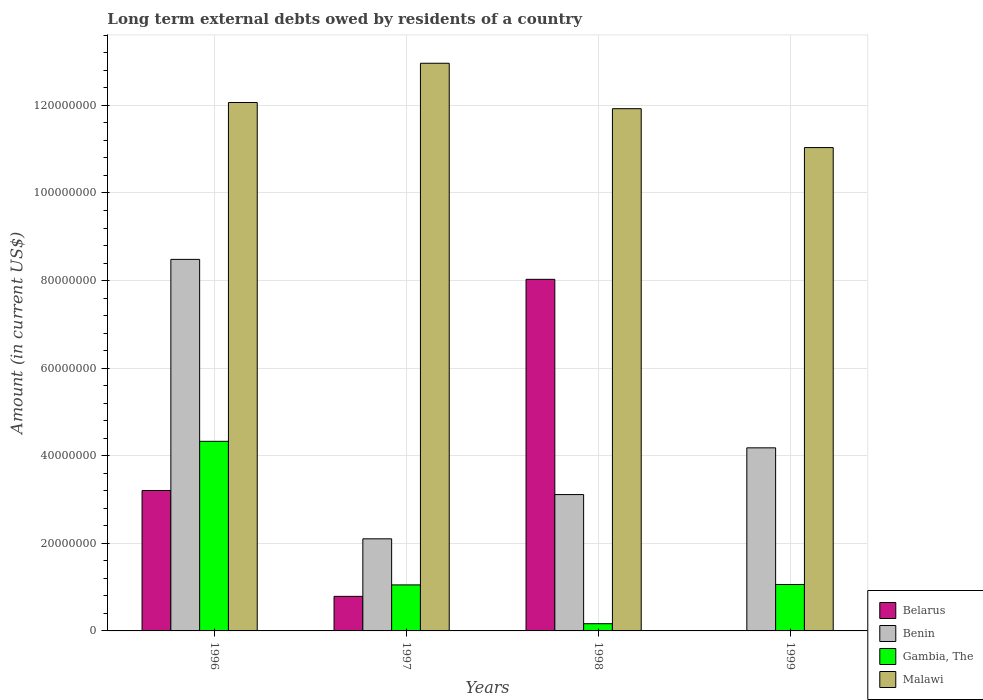Are the number of bars per tick equal to the number of legend labels?
Keep it short and to the point. No. What is the label of the 1st group of bars from the left?
Offer a very short reply. 1996. What is the amount of long-term external debts owed by residents in Gambia, The in 1998?
Your answer should be very brief. 1.65e+06. Across all years, what is the maximum amount of long-term external debts owed by residents in Belarus?
Offer a terse response. 8.03e+07. Across all years, what is the minimum amount of long-term external debts owed by residents in Belarus?
Your answer should be compact. 0. What is the total amount of long-term external debts owed by residents in Benin in the graph?
Your response must be concise. 1.79e+08. What is the difference between the amount of long-term external debts owed by residents in Benin in 1998 and that in 1999?
Give a very brief answer. -1.07e+07. What is the difference between the amount of long-term external debts owed by residents in Malawi in 1997 and the amount of long-term external debts owed by residents in Benin in 1996?
Provide a short and direct response. 4.48e+07. What is the average amount of long-term external debts owed by residents in Gambia, The per year?
Give a very brief answer. 1.65e+07. In the year 1996, what is the difference between the amount of long-term external debts owed by residents in Gambia, The and amount of long-term external debts owed by residents in Belarus?
Offer a terse response. 1.12e+07. What is the ratio of the amount of long-term external debts owed by residents in Benin in 1996 to that in 1998?
Give a very brief answer. 2.72. Is the amount of long-term external debts owed by residents in Malawi in 1997 less than that in 1999?
Ensure brevity in your answer.  No. What is the difference between the highest and the second highest amount of long-term external debts owed by residents in Benin?
Give a very brief answer. 4.30e+07. What is the difference between the highest and the lowest amount of long-term external debts owed by residents in Gambia, The?
Keep it short and to the point. 4.16e+07. In how many years, is the amount of long-term external debts owed by residents in Malawi greater than the average amount of long-term external debts owed by residents in Malawi taken over all years?
Your response must be concise. 2. Is it the case that in every year, the sum of the amount of long-term external debts owed by residents in Benin and amount of long-term external debts owed by residents in Malawi is greater than the sum of amount of long-term external debts owed by residents in Belarus and amount of long-term external debts owed by residents in Gambia, The?
Your answer should be compact. Yes. How many years are there in the graph?
Your answer should be compact. 4. What is the difference between two consecutive major ticks on the Y-axis?
Provide a short and direct response. 2.00e+07. Are the values on the major ticks of Y-axis written in scientific E-notation?
Provide a succinct answer. No. Where does the legend appear in the graph?
Your answer should be very brief. Bottom right. How are the legend labels stacked?
Keep it short and to the point. Vertical. What is the title of the graph?
Your response must be concise. Long term external debts owed by residents of a country. What is the Amount (in current US$) in Belarus in 1996?
Offer a very short reply. 3.21e+07. What is the Amount (in current US$) in Benin in 1996?
Make the answer very short. 8.48e+07. What is the Amount (in current US$) of Gambia, The in 1996?
Provide a short and direct response. 4.33e+07. What is the Amount (in current US$) of Malawi in 1996?
Your answer should be compact. 1.21e+08. What is the Amount (in current US$) of Belarus in 1997?
Provide a short and direct response. 7.89e+06. What is the Amount (in current US$) in Benin in 1997?
Make the answer very short. 2.10e+07. What is the Amount (in current US$) of Gambia, The in 1997?
Offer a very short reply. 1.05e+07. What is the Amount (in current US$) in Malawi in 1997?
Your response must be concise. 1.30e+08. What is the Amount (in current US$) in Belarus in 1998?
Make the answer very short. 8.03e+07. What is the Amount (in current US$) of Benin in 1998?
Offer a very short reply. 3.11e+07. What is the Amount (in current US$) of Gambia, The in 1998?
Offer a very short reply. 1.65e+06. What is the Amount (in current US$) in Malawi in 1998?
Ensure brevity in your answer.  1.19e+08. What is the Amount (in current US$) of Belarus in 1999?
Offer a very short reply. 0. What is the Amount (in current US$) in Benin in 1999?
Keep it short and to the point. 4.18e+07. What is the Amount (in current US$) of Gambia, The in 1999?
Offer a very short reply. 1.06e+07. What is the Amount (in current US$) of Malawi in 1999?
Keep it short and to the point. 1.10e+08. Across all years, what is the maximum Amount (in current US$) of Belarus?
Provide a short and direct response. 8.03e+07. Across all years, what is the maximum Amount (in current US$) of Benin?
Give a very brief answer. 8.48e+07. Across all years, what is the maximum Amount (in current US$) in Gambia, The?
Provide a succinct answer. 4.33e+07. Across all years, what is the maximum Amount (in current US$) of Malawi?
Your answer should be very brief. 1.30e+08. Across all years, what is the minimum Amount (in current US$) in Benin?
Offer a very short reply. 2.10e+07. Across all years, what is the minimum Amount (in current US$) in Gambia, The?
Offer a very short reply. 1.65e+06. Across all years, what is the minimum Amount (in current US$) in Malawi?
Ensure brevity in your answer.  1.10e+08. What is the total Amount (in current US$) in Belarus in the graph?
Provide a short and direct response. 1.20e+08. What is the total Amount (in current US$) of Benin in the graph?
Provide a succinct answer. 1.79e+08. What is the total Amount (in current US$) in Gambia, The in the graph?
Your answer should be very brief. 6.60e+07. What is the total Amount (in current US$) of Malawi in the graph?
Provide a succinct answer. 4.80e+08. What is the difference between the Amount (in current US$) of Belarus in 1996 and that in 1997?
Your answer should be compact. 2.42e+07. What is the difference between the Amount (in current US$) of Benin in 1996 and that in 1997?
Ensure brevity in your answer.  6.38e+07. What is the difference between the Amount (in current US$) of Gambia, The in 1996 and that in 1997?
Offer a very short reply. 3.28e+07. What is the difference between the Amount (in current US$) in Malawi in 1996 and that in 1997?
Provide a short and direct response. -8.96e+06. What is the difference between the Amount (in current US$) of Belarus in 1996 and that in 1998?
Make the answer very short. -4.82e+07. What is the difference between the Amount (in current US$) in Benin in 1996 and that in 1998?
Keep it short and to the point. 5.37e+07. What is the difference between the Amount (in current US$) of Gambia, The in 1996 and that in 1998?
Keep it short and to the point. 4.16e+07. What is the difference between the Amount (in current US$) in Malawi in 1996 and that in 1998?
Give a very brief answer. 1.41e+06. What is the difference between the Amount (in current US$) in Benin in 1996 and that in 1999?
Your answer should be very brief. 4.30e+07. What is the difference between the Amount (in current US$) in Gambia, The in 1996 and that in 1999?
Your answer should be very brief. 3.27e+07. What is the difference between the Amount (in current US$) of Malawi in 1996 and that in 1999?
Your answer should be very brief. 1.03e+07. What is the difference between the Amount (in current US$) in Belarus in 1997 and that in 1998?
Offer a very short reply. -7.24e+07. What is the difference between the Amount (in current US$) in Benin in 1997 and that in 1998?
Your response must be concise. -1.01e+07. What is the difference between the Amount (in current US$) in Gambia, The in 1997 and that in 1998?
Offer a terse response. 8.86e+06. What is the difference between the Amount (in current US$) in Malawi in 1997 and that in 1998?
Make the answer very short. 1.04e+07. What is the difference between the Amount (in current US$) of Benin in 1997 and that in 1999?
Make the answer very short. -2.08e+07. What is the difference between the Amount (in current US$) in Gambia, The in 1997 and that in 1999?
Your answer should be compact. -8.70e+04. What is the difference between the Amount (in current US$) in Malawi in 1997 and that in 1999?
Offer a terse response. 1.93e+07. What is the difference between the Amount (in current US$) of Benin in 1998 and that in 1999?
Keep it short and to the point. -1.07e+07. What is the difference between the Amount (in current US$) in Gambia, The in 1998 and that in 1999?
Offer a terse response. -8.95e+06. What is the difference between the Amount (in current US$) of Malawi in 1998 and that in 1999?
Your answer should be very brief. 8.88e+06. What is the difference between the Amount (in current US$) in Belarus in 1996 and the Amount (in current US$) in Benin in 1997?
Keep it short and to the point. 1.10e+07. What is the difference between the Amount (in current US$) in Belarus in 1996 and the Amount (in current US$) in Gambia, The in 1997?
Provide a succinct answer. 2.16e+07. What is the difference between the Amount (in current US$) in Belarus in 1996 and the Amount (in current US$) in Malawi in 1997?
Offer a very short reply. -9.76e+07. What is the difference between the Amount (in current US$) of Benin in 1996 and the Amount (in current US$) of Gambia, The in 1997?
Make the answer very short. 7.43e+07. What is the difference between the Amount (in current US$) of Benin in 1996 and the Amount (in current US$) of Malawi in 1997?
Ensure brevity in your answer.  -4.48e+07. What is the difference between the Amount (in current US$) of Gambia, The in 1996 and the Amount (in current US$) of Malawi in 1997?
Your answer should be very brief. -8.63e+07. What is the difference between the Amount (in current US$) of Belarus in 1996 and the Amount (in current US$) of Benin in 1998?
Offer a terse response. 9.32e+05. What is the difference between the Amount (in current US$) of Belarus in 1996 and the Amount (in current US$) of Gambia, The in 1998?
Ensure brevity in your answer.  3.04e+07. What is the difference between the Amount (in current US$) of Belarus in 1996 and the Amount (in current US$) of Malawi in 1998?
Your response must be concise. -8.72e+07. What is the difference between the Amount (in current US$) in Benin in 1996 and the Amount (in current US$) in Gambia, The in 1998?
Offer a terse response. 8.32e+07. What is the difference between the Amount (in current US$) of Benin in 1996 and the Amount (in current US$) of Malawi in 1998?
Make the answer very short. -3.44e+07. What is the difference between the Amount (in current US$) of Gambia, The in 1996 and the Amount (in current US$) of Malawi in 1998?
Ensure brevity in your answer.  -7.60e+07. What is the difference between the Amount (in current US$) of Belarus in 1996 and the Amount (in current US$) of Benin in 1999?
Make the answer very short. -9.74e+06. What is the difference between the Amount (in current US$) in Belarus in 1996 and the Amount (in current US$) in Gambia, The in 1999?
Your answer should be very brief. 2.15e+07. What is the difference between the Amount (in current US$) of Belarus in 1996 and the Amount (in current US$) of Malawi in 1999?
Give a very brief answer. -7.83e+07. What is the difference between the Amount (in current US$) of Benin in 1996 and the Amount (in current US$) of Gambia, The in 1999?
Make the answer very short. 7.42e+07. What is the difference between the Amount (in current US$) of Benin in 1996 and the Amount (in current US$) of Malawi in 1999?
Ensure brevity in your answer.  -2.55e+07. What is the difference between the Amount (in current US$) in Gambia, The in 1996 and the Amount (in current US$) in Malawi in 1999?
Ensure brevity in your answer.  -6.71e+07. What is the difference between the Amount (in current US$) in Belarus in 1997 and the Amount (in current US$) in Benin in 1998?
Offer a very short reply. -2.32e+07. What is the difference between the Amount (in current US$) of Belarus in 1997 and the Amount (in current US$) of Gambia, The in 1998?
Your answer should be compact. 6.25e+06. What is the difference between the Amount (in current US$) of Belarus in 1997 and the Amount (in current US$) of Malawi in 1998?
Offer a terse response. -1.11e+08. What is the difference between the Amount (in current US$) in Benin in 1997 and the Amount (in current US$) in Gambia, The in 1998?
Keep it short and to the point. 1.94e+07. What is the difference between the Amount (in current US$) in Benin in 1997 and the Amount (in current US$) in Malawi in 1998?
Make the answer very short. -9.82e+07. What is the difference between the Amount (in current US$) in Gambia, The in 1997 and the Amount (in current US$) in Malawi in 1998?
Keep it short and to the point. -1.09e+08. What is the difference between the Amount (in current US$) in Belarus in 1997 and the Amount (in current US$) in Benin in 1999?
Keep it short and to the point. -3.39e+07. What is the difference between the Amount (in current US$) in Belarus in 1997 and the Amount (in current US$) in Gambia, The in 1999?
Offer a very short reply. -2.70e+06. What is the difference between the Amount (in current US$) in Belarus in 1997 and the Amount (in current US$) in Malawi in 1999?
Provide a short and direct response. -1.02e+08. What is the difference between the Amount (in current US$) in Benin in 1997 and the Amount (in current US$) in Gambia, The in 1999?
Offer a terse response. 1.04e+07. What is the difference between the Amount (in current US$) in Benin in 1997 and the Amount (in current US$) in Malawi in 1999?
Provide a succinct answer. -8.93e+07. What is the difference between the Amount (in current US$) in Gambia, The in 1997 and the Amount (in current US$) in Malawi in 1999?
Ensure brevity in your answer.  -9.99e+07. What is the difference between the Amount (in current US$) in Belarus in 1998 and the Amount (in current US$) in Benin in 1999?
Ensure brevity in your answer.  3.85e+07. What is the difference between the Amount (in current US$) in Belarus in 1998 and the Amount (in current US$) in Gambia, The in 1999?
Provide a succinct answer. 6.97e+07. What is the difference between the Amount (in current US$) of Belarus in 1998 and the Amount (in current US$) of Malawi in 1999?
Make the answer very short. -3.01e+07. What is the difference between the Amount (in current US$) of Benin in 1998 and the Amount (in current US$) of Gambia, The in 1999?
Make the answer very short. 2.05e+07. What is the difference between the Amount (in current US$) of Benin in 1998 and the Amount (in current US$) of Malawi in 1999?
Provide a succinct answer. -7.92e+07. What is the difference between the Amount (in current US$) in Gambia, The in 1998 and the Amount (in current US$) in Malawi in 1999?
Give a very brief answer. -1.09e+08. What is the average Amount (in current US$) of Belarus per year?
Keep it short and to the point. 3.01e+07. What is the average Amount (in current US$) of Benin per year?
Your response must be concise. 4.47e+07. What is the average Amount (in current US$) in Gambia, The per year?
Your answer should be compact. 1.65e+07. What is the average Amount (in current US$) in Malawi per year?
Your answer should be very brief. 1.20e+08. In the year 1996, what is the difference between the Amount (in current US$) in Belarus and Amount (in current US$) in Benin?
Keep it short and to the point. -5.28e+07. In the year 1996, what is the difference between the Amount (in current US$) of Belarus and Amount (in current US$) of Gambia, The?
Make the answer very short. -1.12e+07. In the year 1996, what is the difference between the Amount (in current US$) in Belarus and Amount (in current US$) in Malawi?
Your answer should be compact. -8.86e+07. In the year 1996, what is the difference between the Amount (in current US$) of Benin and Amount (in current US$) of Gambia, The?
Make the answer very short. 4.15e+07. In the year 1996, what is the difference between the Amount (in current US$) of Benin and Amount (in current US$) of Malawi?
Give a very brief answer. -3.58e+07. In the year 1996, what is the difference between the Amount (in current US$) in Gambia, The and Amount (in current US$) in Malawi?
Keep it short and to the point. -7.74e+07. In the year 1997, what is the difference between the Amount (in current US$) in Belarus and Amount (in current US$) in Benin?
Your response must be concise. -1.31e+07. In the year 1997, what is the difference between the Amount (in current US$) in Belarus and Amount (in current US$) in Gambia, The?
Give a very brief answer. -2.62e+06. In the year 1997, what is the difference between the Amount (in current US$) in Belarus and Amount (in current US$) in Malawi?
Your response must be concise. -1.22e+08. In the year 1997, what is the difference between the Amount (in current US$) of Benin and Amount (in current US$) of Gambia, The?
Keep it short and to the point. 1.05e+07. In the year 1997, what is the difference between the Amount (in current US$) in Benin and Amount (in current US$) in Malawi?
Give a very brief answer. -1.09e+08. In the year 1997, what is the difference between the Amount (in current US$) of Gambia, The and Amount (in current US$) of Malawi?
Offer a terse response. -1.19e+08. In the year 1998, what is the difference between the Amount (in current US$) of Belarus and Amount (in current US$) of Benin?
Offer a very short reply. 4.92e+07. In the year 1998, what is the difference between the Amount (in current US$) of Belarus and Amount (in current US$) of Gambia, The?
Your answer should be compact. 7.86e+07. In the year 1998, what is the difference between the Amount (in current US$) in Belarus and Amount (in current US$) in Malawi?
Keep it short and to the point. -3.90e+07. In the year 1998, what is the difference between the Amount (in current US$) of Benin and Amount (in current US$) of Gambia, The?
Make the answer very short. 2.95e+07. In the year 1998, what is the difference between the Amount (in current US$) in Benin and Amount (in current US$) in Malawi?
Your answer should be very brief. -8.81e+07. In the year 1998, what is the difference between the Amount (in current US$) of Gambia, The and Amount (in current US$) of Malawi?
Make the answer very short. -1.18e+08. In the year 1999, what is the difference between the Amount (in current US$) in Benin and Amount (in current US$) in Gambia, The?
Your response must be concise. 3.12e+07. In the year 1999, what is the difference between the Amount (in current US$) in Benin and Amount (in current US$) in Malawi?
Give a very brief answer. -6.86e+07. In the year 1999, what is the difference between the Amount (in current US$) of Gambia, The and Amount (in current US$) of Malawi?
Make the answer very short. -9.98e+07. What is the ratio of the Amount (in current US$) in Belarus in 1996 to that in 1997?
Provide a succinct answer. 4.06. What is the ratio of the Amount (in current US$) of Benin in 1996 to that in 1997?
Make the answer very short. 4.03. What is the ratio of the Amount (in current US$) of Gambia, The in 1996 to that in 1997?
Keep it short and to the point. 4.12. What is the ratio of the Amount (in current US$) in Malawi in 1996 to that in 1997?
Keep it short and to the point. 0.93. What is the ratio of the Amount (in current US$) of Belarus in 1996 to that in 1998?
Your answer should be very brief. 0.4. What is the ratio of the Amount (in current US$) of Benin in 1996 to that in 1998?
Provide a short and direct response. 2.72. What is the ratio of the Amount (in current US$) of Gambia, The in 1996 to that in 1998?
Provide a succinct answer. 26.27. What is the ratio of the Amount (in current US$) in Malawi in 1996 to that in 1998?
Provide a short and direct response. 1.01. What is the ratio of the Amount (in current US$) in Benin in 1996 to that in 1999?
Make the answer very short. 2.03. What is the ratio of the Amount (in current US$) of Gambia, The in 1996 to that in 1999?
Provide a succinct answer. 4.09. What is the ratio of the Amount (in current US$) in Malawi in 1996 to that in 1999?
Make the answer very short. 1.09. What is the ratio of the Amount (in current US$) of Belarus in 1997 to that in 1998?
Make the answer very short. 0.1. What is the ratio of the Amount (in current US$) of Benin in 1997 to that in 1998?
Give a very brief answer. 0.68. What is the ratio of the Amount (in current US$) in Gambia, The in 1997 to that in 1998?
Your response must be concise. 6.38. What is the ratio of the Amount (in current US$) in Malawi in 1997 to that in 1998?
Your answer should be compact. 1.09. What is the ratio of the Amount (in current US$) in Benin in 1997 to that in 1999?
Ensure brevity in your answer.  0.5. What is the ratio of the Amount (in current US$) of Malawi in 1997 to that in 1999?
Offer a terse response. 1.17. What is the ratio of the Amount (in current US$) of Benin in 1998 to that in 1999?
Keep it short and to the point. 0.74. What is the ratio of the Amount (in current US$) in Gambia, The in 1998 to that in 1999?
Give a very brief answer. 0.16. What is the ratio of the Amount (in current US$) of Malawi in 1998 to that in 1999?
Provide a succinct answer. 1.08. What is the difference between the highest and the second highest Amount (in current US$) of Belarus?
Ensure brevity in your answer.  4.82e+07. What is the difference between the highest and the second highest Amount (in current US$) in Benin?
Give a very brief answer. 4.30e+07. What is the difference between the highest and the second highest Amount (in current US$) of Gambia, The?
Provide a succinct answer. 3.27e+07. What is the difference between the highest and the second highest Amount (in current US$) in Malawi?
Your answer should be compact. 8.96e+06. What is the difference between the highest and the lowest Amount (in current US$) in Belarus?
Your answer should be very brief. 8.03e+07. What is the difference between the highest and the lowest Amount (in current US$) of Benin?
Offer a terse response. 6.38e+07. What is the difference between the highest and the lowest Amount (in current US$) in Gambia, The?
Ensure brevity in your answer.  4.16e+07. What is the difference between the highest and the lowest Amount (in current US$) of Malawi?
Offer a terse response. 1.93e+07. 